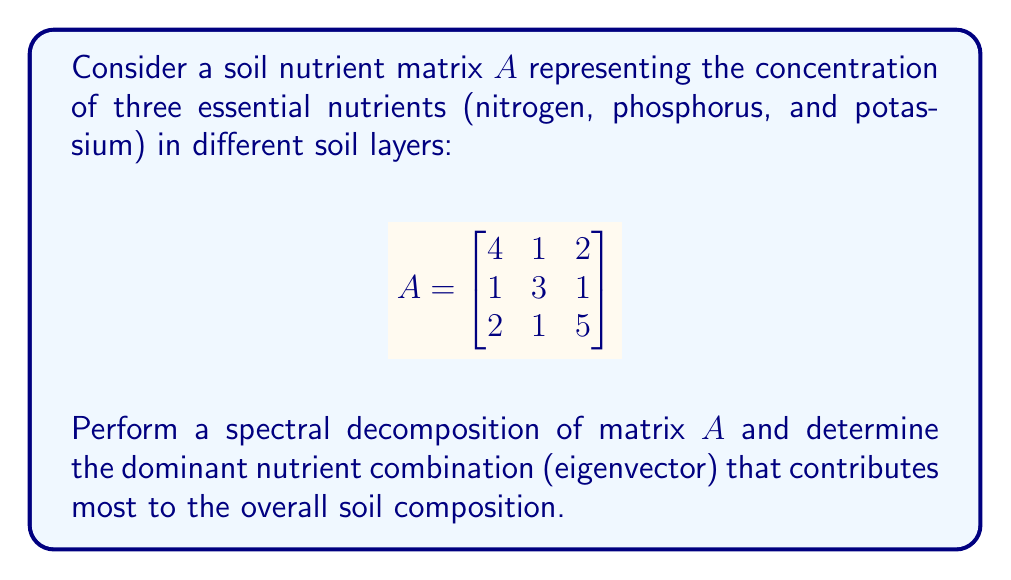Solve this math problem. 1) To perform spectral decomposition, we need to find the eigenvalues and eigenvectors of $A$.

2) The characteristic equation is:
   $$det(A - \lambda I) = \begin{vmatrix}
   4-\lambda & 1 & 2 \\
   1 & 3-\lambda & 1 \\
   2 & 1 & 5-\lambda
   \end{vmatrix} = 0$$

3) Expanding this determinant:
   $(\lambda-4)(\lambda-3)(\lambda-5) - 2(\lambda-3) - 2(\lambda-4) - (\lambda-5) = 0$
   $\lambda^3 - 12\lambda^2 + 44\lambda - 48 = 0$

4) Solving this equation (using a calculator or computer algebra system), we get:
   $\lambda_1 \approx 6.86$, $\lambda_2 \approx 3.61$, $\lambda_3 \approx 1.53$

5) The largest eigenvalue is $\lambda_1 \approx 6.86$. This corresponds to the dominant nutrient combination.

6) To find the eigenvector $v_1$ for $\lambda_1$, solve $(A - \lambda_1 I)v_1 = 0$:

   $$\begin{bmatrix}
   -2.86 & 1 & 2 \\
   1 & -3.86 & 1 \\
   2 & 1 & -1.86
   \end{bmatrix} \begin{bmatrix} x \\ y \\ z \end{bmatrix} = \begin{bmatrix} 0 \\ 0 \\ 0 \end{bmatrix}$$

7) Solving this system (and normalizing), we get:
   $v_1 \approx [0.52, 0.37, 0.77]^T$

8) This eigenvector represents the dominant nutrient combination, with the components corresponding to nitrogen, phosphorus, and potassium respectively.
Answer: $[0.52, 0.37, 0.77]^T$ 